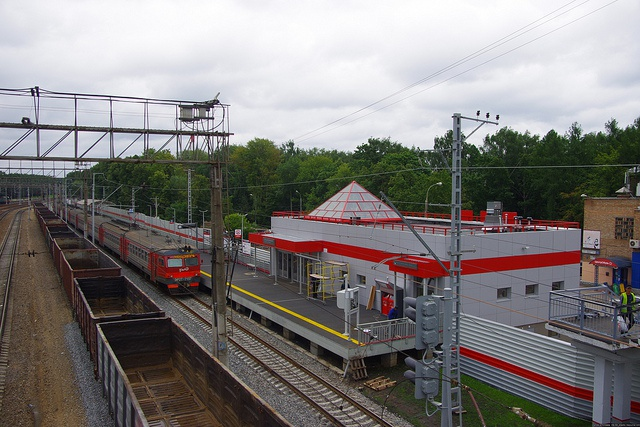Describe the objects in this image and their specific colors. I can see train in lightgray, gray, black, maroon, and brown tones, traffic light in lightgray, gray, black, and darkblue tones, people in lightgray, black, gray, darkgreen, and maroon tones, traffic light in lightgray, gray, and black tones, and people in lightgray, black, darkgreen, and navy tones in this image. 